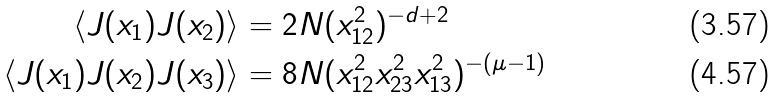<formula> <loc_0><loc_0><loc_500><loc_500>\langle J ( x _ { 1 } ) J ( x _ { 2 } ) \rangle & = 2 N ( x _ { 1 2 } ^ { 2 } ) ^ { - d + 2 } \\ \langle J ( x _ { 1 } ) J ( x _ { 2 } ) J ( x _ { 3 } ) \rangle & = 8 N ( x _ { 1 2 } ^ { 2 } x _ { 2 3 } ^ { 2 } x _ { 1 3 } ^ { 2 } ) ^ { - ( \mu - 1 ) }</formula> 